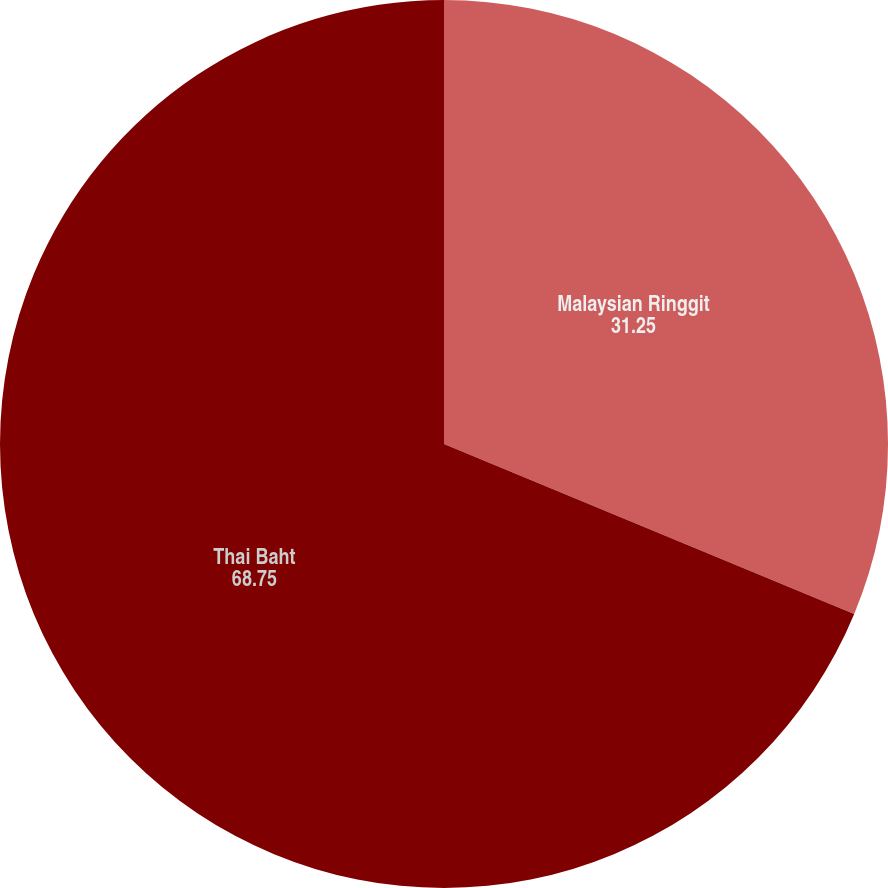Convert chart. <chart><loc_0><loc_0><loc_500><loc_500><pie_chart><fcel>Malaysian Ringgit<fcel>Thai Baht<nl><fcel>31.25%<fcel>68.75%<nl></chart> 